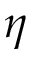Convert formula to latex. <formula><loc_0><loc_0><loc_500><loc_500>\eta</formula> 